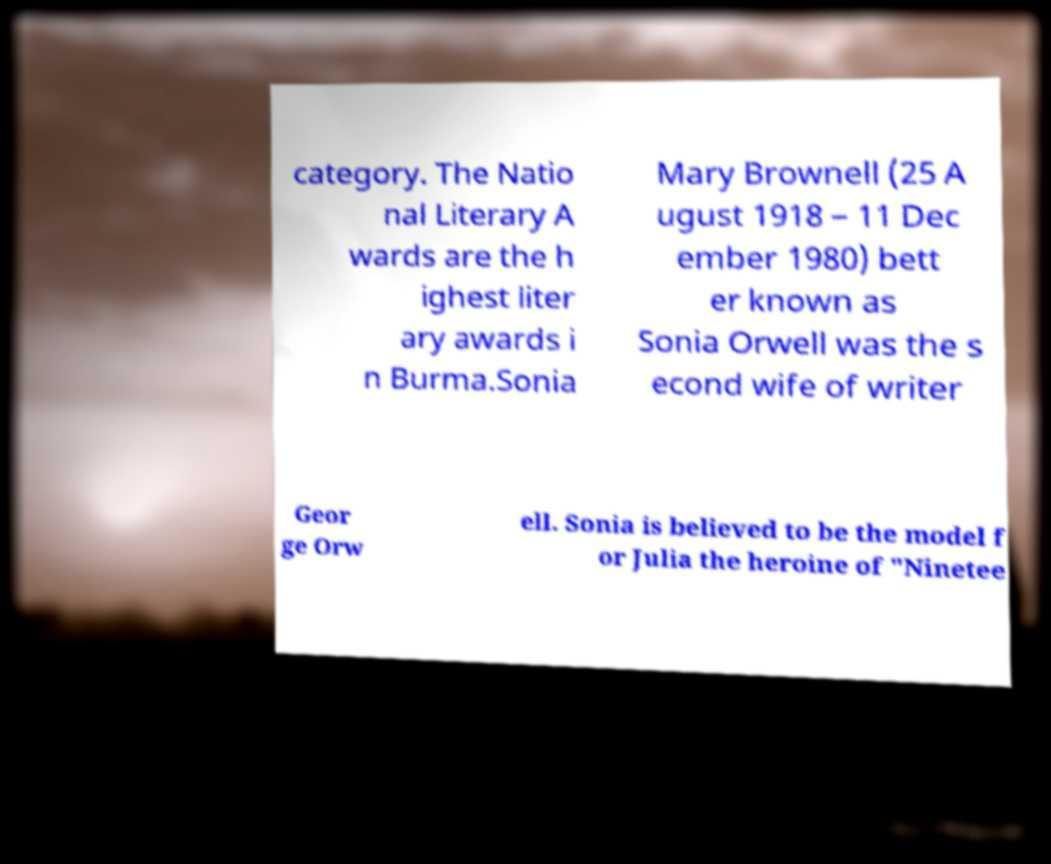Please read and relay the text visible in this image. What does it say? category. The Natio nal Literary A wards are the h ighest liter ary awards i n Burma.Sonia Mary Brownell (25 A ugust 1918 – 11 Dec ember 1980) bett er known as Sonia Orwell was the s econd wife of writer Geor ge Orw ell. Sonia is believed to be the model f or Julia the heroine of "Ninetee 